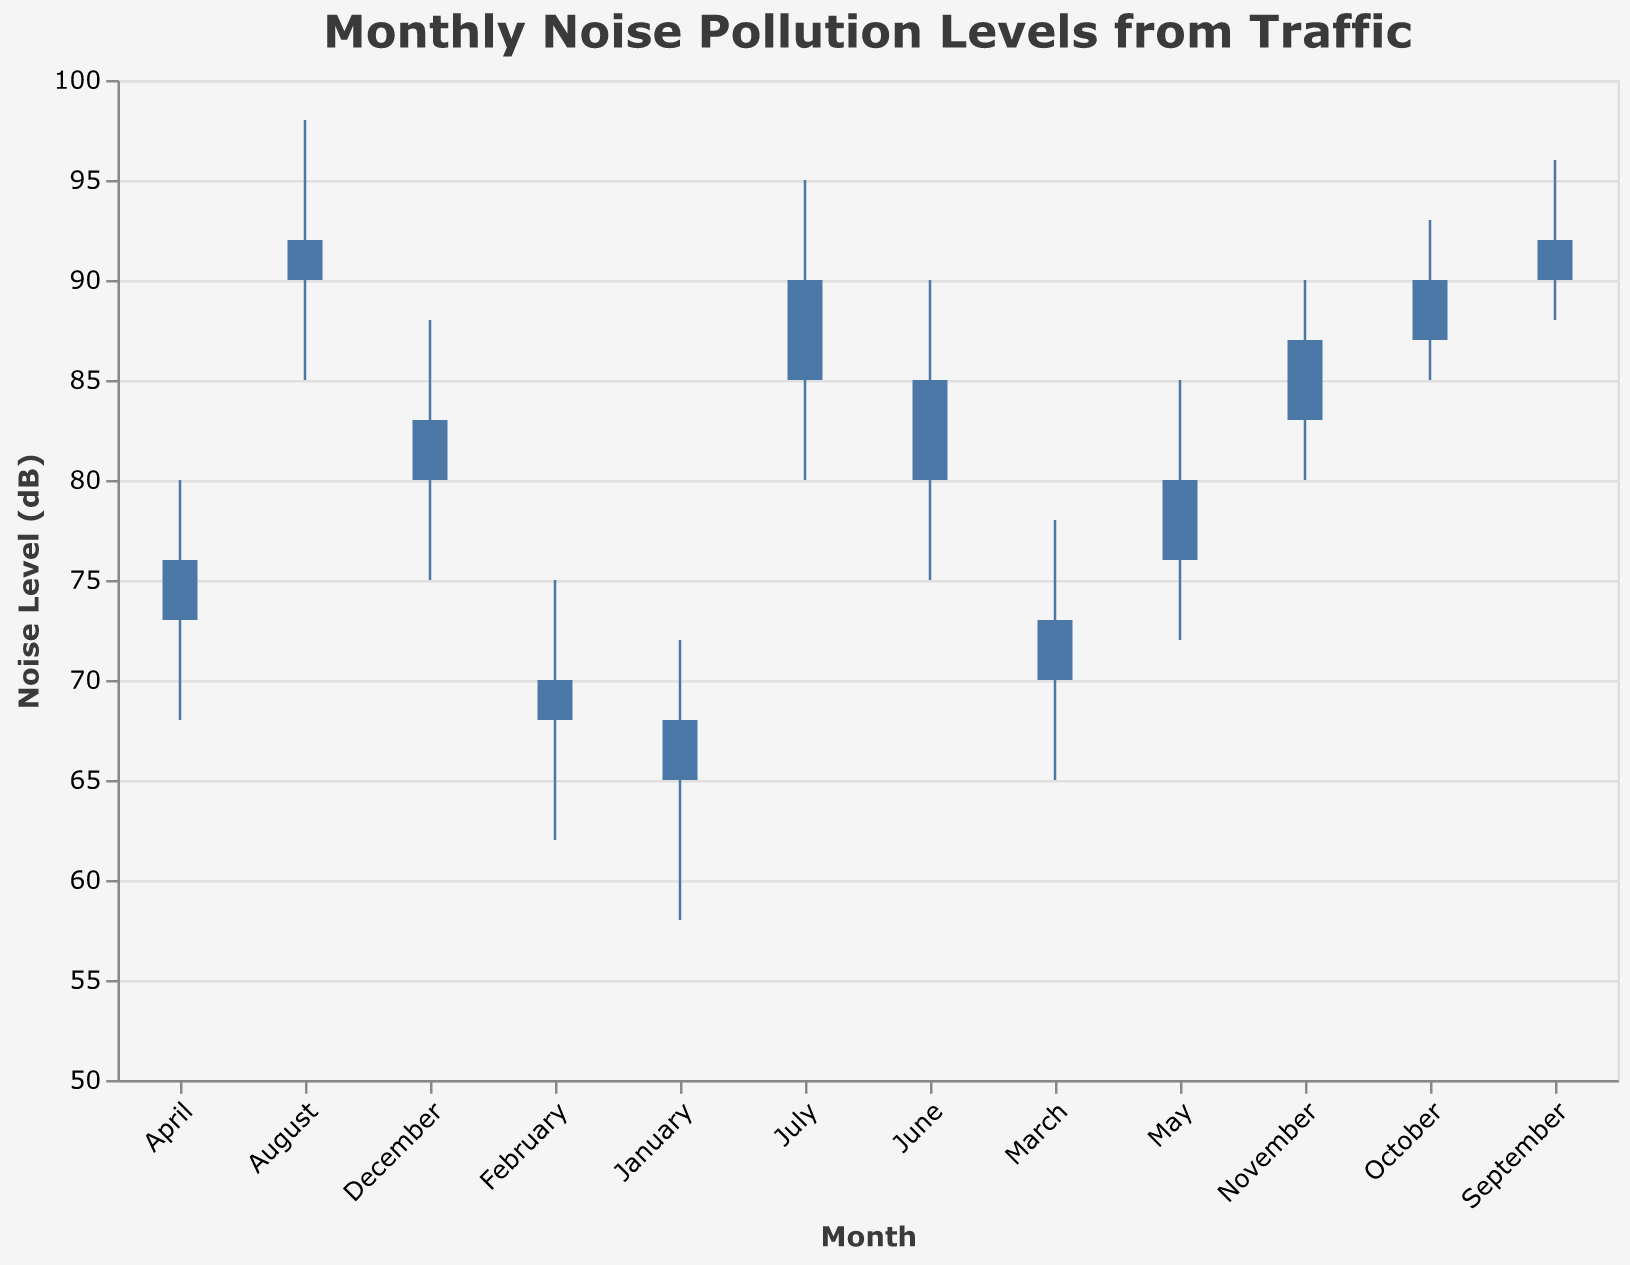What is the highest noise level recorded in January? The highest noise level in January is the value at the highest point of the vertical bar in the figure for January.
Answer: 72 Which month shows the largest difference between the open and close values? The difference between the open and close values for each month can be calculated and compared. The month with the highest difference will have the largest gap between these two values. For example, for January, the difference is 68 - 65 = 3, and so on. The month with the highest gap is June with a difference of 85 - 80 = 5.
Answer: June What seasonal pattern can be observed in the noise pollution levels from traffic? Observing the entire chart visually, one can see that the noise levels rise during the summer months (June, July, and August) and decline in the winter months (November, December, January). This seasonal trend reflects higher noise pollution in summer and lower in winter.
Answer: Higher in summer, lower in winter Which month has the lowest recorded noise level? The lowest recorded noise level is the smallest value among all 'Low' values listed in the figure. By viewing each month's low value, we can find the minimum. The lowest value is 58 dB in January.
Answer: January How does the noise level in November compare to the noise level in June? To compare the noise levels between two months, observe their high, low, open, and close values. November's values are lower overall compared to June's figures. Specifically, the highest in November is 90, and the highest in June is 90; the lowest in November is 80, while in June, it is 75. June's overall trend is higher.
Answer: November has lower levels than June What is the average highest noise level for the months June, July, and August? The highest noise levels for June, July, and August are 90, 95, and 98 respectively. Sum them up: 90 + 95 + 98 = 283, and then divide by 3 to get the average: 283/3 = 94.33
Answer: 94.33 Which month has the smallest range between its high and low noise levels? The range between high and low values for each month needs to be calculated, and the smallest difference identifies the month. For example, January's range is 72 - 58 = 14, February's is 75 - 62 = 13, and so forth. October has the smallest range of 8 dB (93 - 85 = 8).
Answer: October 